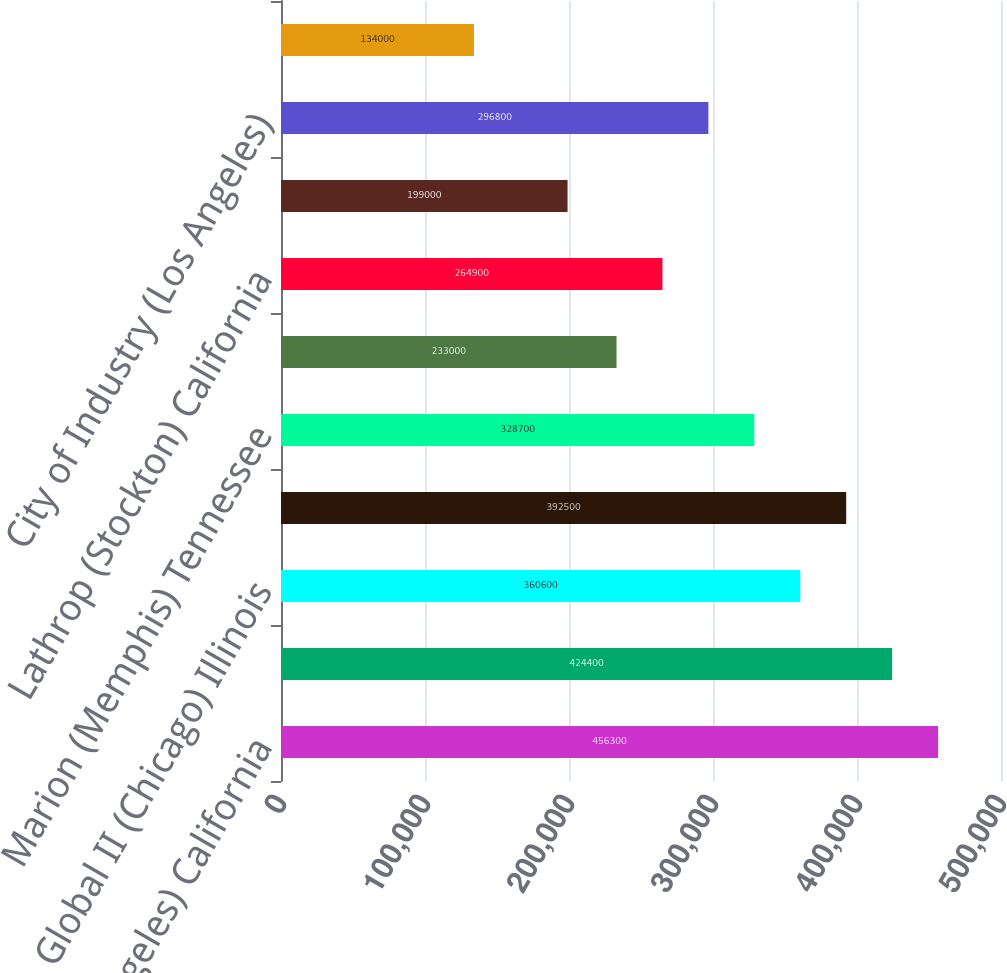Convert chart to OTSL. <chart><loc_0><loc_0><loc_500><loc_500><bar_chart><fcel>ICTF (Los Angeles) California<fcel>East Los Angeles California<fcel>Global II (Chicago) Illinois<fcel>Global I (Chicago) Illinois<fcel>Marion (Memphis) Tennessee<fcel>Dallas Texas<fcel>Lathrop (Stockton) California<fcel>Yard Center (Chicago) Illinois<fcel>City of Industry (Los Angeles)<fcel>LATC (Los Angeles) California<nl><fcel>456300<fcel>424400<fcel>360600<fcel>392500<fcel>328700<fcel>233000<fcel>264900<fcel>199000<fcel>296800<fcel>134000<nl></chart> 